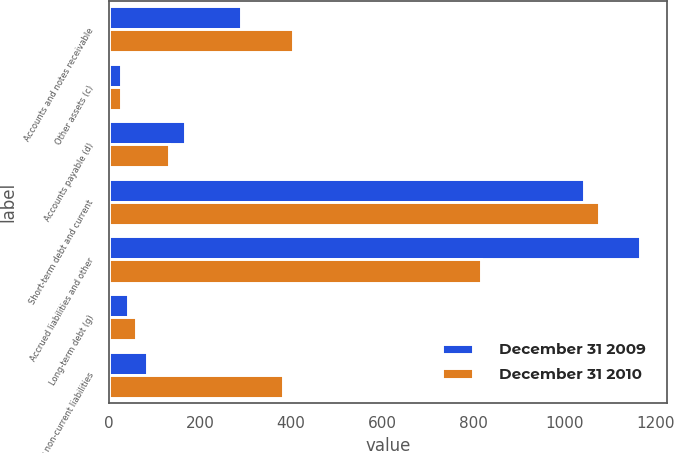<chart> <loc_0><loc_0><loc_500><loc_500><stacked_bar_chart><ecel><fcel>Accounts and notes receivable<fcel>Other assets (c)<fcel>Accounts payable (d)<fcel>Short-term debt and current<fcel>Accrued liabilities and other<fcel>Long-term debt (g)<fcel>Other non-current liabilities<nl><fcel>December 31 2009<fcel>290<fcel>26<fcel>168<fcel>1043<fcel>1167<fcel>43<fcel>84<nl><fcel>December 31 2010<fcel>404<fcel>27<fcel>131<fcel>1077<fcel>817<fcel>59<fcel>383<nl></chart> 